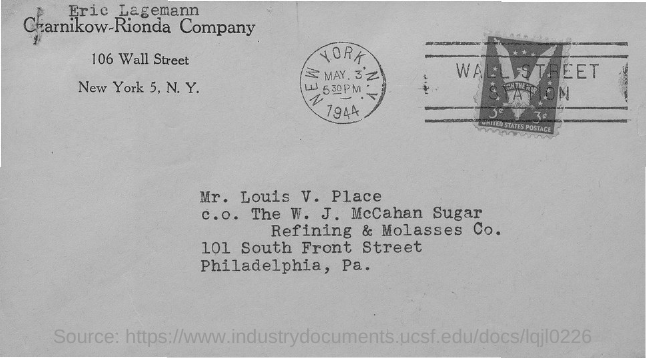What is the Date?
Your answer should be compact. May 3, 1944. To Whom is this letter addressed to?
Your answer should be compact. MR. LOUIS V. PLACE. Who is this letter from?
Your response must be concise. ERIC LAGEMANN. Which city name is on the round shaped stamp?
Ensure brevity in your answer.  NEW YORK. N.Y. 